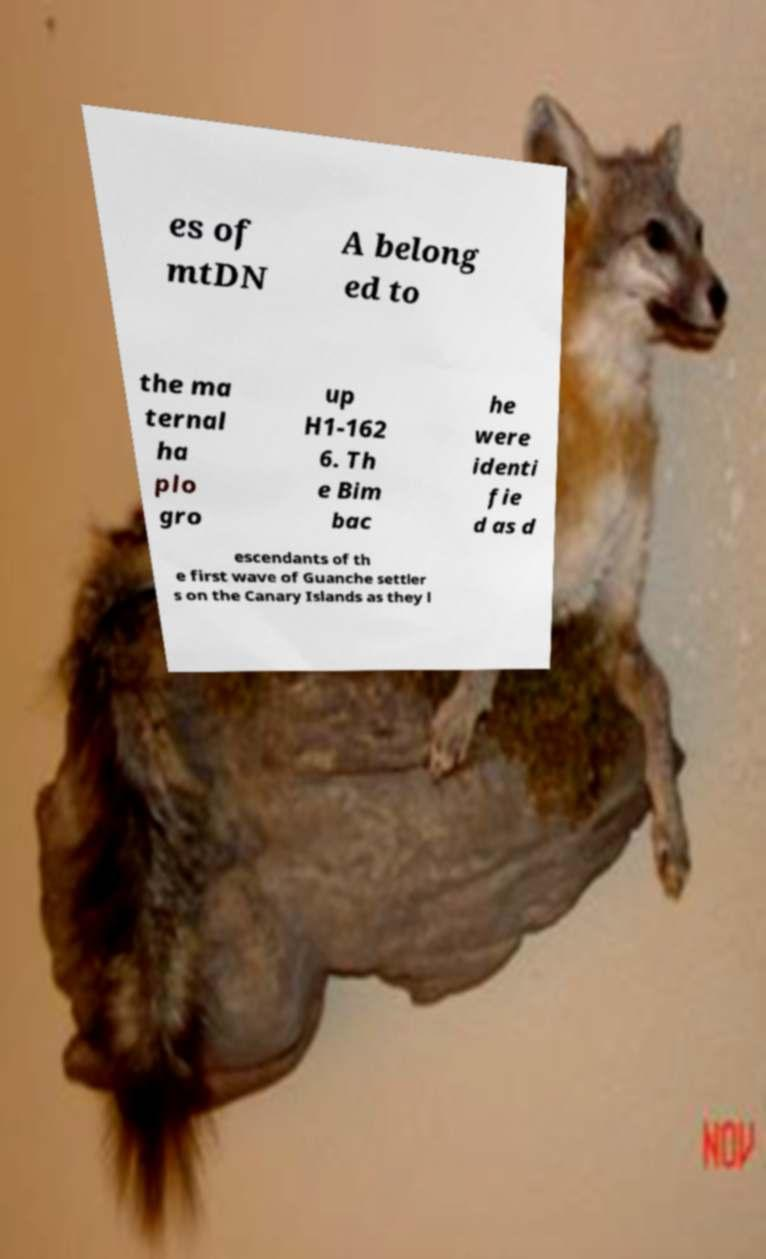Please read and relay the text visible in this image. What does it say? es of mtDN A belong ed to the ma ternal ha plo gro up H1-162 6. Th e Bim bac he were identi fie d as d escendants of th e first wave of Guanche settler s on the Canary Islands as they l 